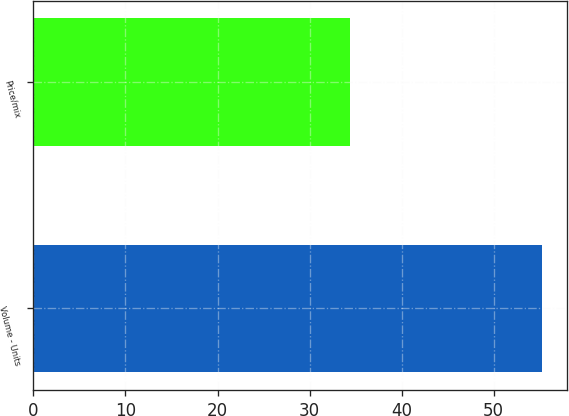Convert chart. <chart><loc_0><loc_0><loc_500><loc_500><bar_chart><fcel>Volume - Units<fcel>Price/mix<nl><fcel>55.2<fcel>34.4<nl></chart> 